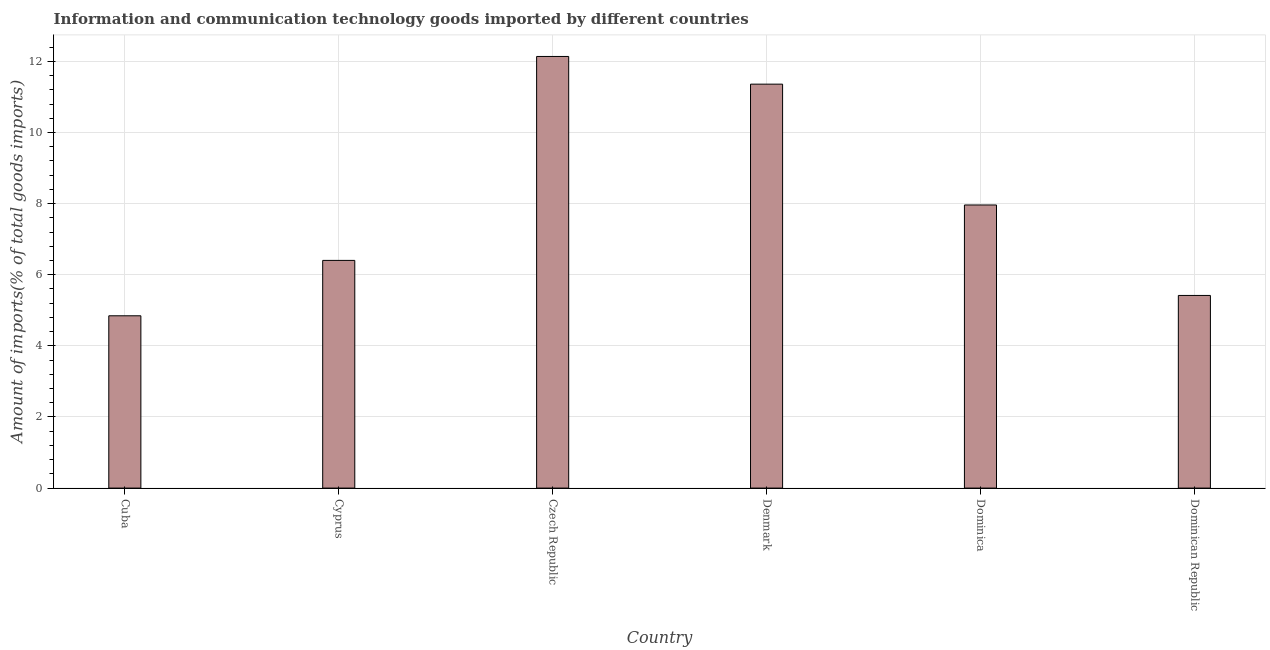Does the graph contain any zero values?
Make the answer very short. No. What is the title of the graph?
Give a very brief answer. Information and communication technology goods imported by different countries. What is the label or title of the X-axis?
Offer a very short reply. Country. What is the label or title of the Y-axis?
Give a very brief answer. Amount of imports(% of total goods imports). What is the amount of ict goods imports in Denmark?
Your answer should be compact. 11.36. Across all countries, what is the maximum amount of ict goods imports?
Your answer should be compact. 12.14. Across all countries, what is the minimum amount of ict goods imports?
Offer a very short reply. 4.85. In which country was the amount of ict goods imports maximum?
Your response must be concise. Czech Republic. In which country was the amount of ict goods imports minimum?
Your answer should be very brief. Cuba. What is the sum of the amount of ict goods imports?
Make the answer very short. 48.12. What is the difference between the amount of ict goods imports in Cuba and Dominican Republic?
Give a very brief answer. -0.57. What is the average amount of ict goods imports per country?
Offer a terse response. 8.02. What is the median amount of ict goods imports?
Keep it short and to the point. 7.18. In how many countries, is the amount of ict goods imports greater than 4.4 %?
Offer a very short reply. 6. What is the ratio of the amount of ict goods imports in Czech Republic to that in Denmark?
Ensure brevity in your answer.  1.07. Is the amount of ict goods imports in Cuba less than that in Czech Republic?
Your answer should be compact. Yes. What is the difference between the highest and the second highest amount of ict goods imports?
Offer a terse response. 0.78. Is the sum of the amount of ict goods imports in Cuba and Dominica greater than the maximum amount of ict goods imports across all countries?
Give a very brief answer. Yes. What is the difference between the highest and the lowest amount of ict goods imports?
Provide a succinct answer. 7.29. In how many countries, is the amount of ict goods imports greater than the average amount of ict goods imports taken over all countries?
Offer a terse response. 2. How many bars are there?
Offer a terse response. 6. Are all the bars in the graph horizontal?
Your answer should be compact. No. How many countries are there in the graph?
Give a very brief answer. 6. What is the difference between two consecutive major ticks on the Y-axis?
Give a very brief answer. 2. What is the Amount of imports(% of total goods imports) in Cuba?
Make the answer very short. 4.85. What is the Amount of imports(% of total goods imports) in Cyprus?
Give a very brief answer. 6.4. What is the Amount of imports(% of total goods imports) of Czech Republic?
Your response must be concise. 12.14. What is the Amount of imports(% of total goods imports) of Denmark?
Give a very brief answer. 11.36. What is the Amount of imports(% of total goods imports) of Dominica?
Make the answer very short. 7.96. What is the Amount of imports(% of total goods imports) in Dominican Republic?
Give a very brief answer. 5.42. What is the difference between the Amount of imports(% of total goods imports) in Cuba and Cyprus?
Offer a terse response. -1.56. What is the difference between the Amount of imports(% of total goods imports) in Cuba and Czech Republic?
Ensure brevity in your answer.  -7.29. What is the difference between the Amount of imports(% of total goods imports) in Cuba and Denmark?
Keep it short and to the point. -6.51. What is the difference between the Amount of imports(% of total goods imports) in Cuba and Dominica?
Make the answer very short. -3.12. What is the difference between the Amount of imports(% of total goods imports) in Cuba and Dominican Republic?
Offer a terse response. -0.57. What is the difference between the Amount of imports(% of total goods imports) in Cyprus and Czech Republic?
Make the answer very short. -5.73. What is the difference between the Amount of imports(% of total goods imports) in Cyprus and Denmark?
Your answer should be compact. -4.96. What is the difference between the Amount of imports(% of total goods imports) in Cyprus and Dominica?
Offer a terse response. -1.56. What is the difference between the Amount of imports(% of total goods imports) in Cyprus and Dominican Republic?
Provide a short and direct response. 0.99. What is the difference between the Amount of imports(% of total goods imports) in Czech Republic and Denmark?
Offer a terse response. 0.78. What is the difference between the Amount of imports(% of total goods imports) in Czech Republic and Dominica?
Your response must be concise. 4.18. What is the difference between the Amount of imports(% of total goods imports) in Czech Republic and Dominican Republic?
Ensure brevity in your answer.  6.72. What is the difference between the Amount of imports(% of total goods imports) in Denmark and Dominica?
Keep it short and to the point. 3.4. What is the difference between the Amount of imports(% of total goods imports) in Denmark and Dominican Republic?
Your response must be concise. 5.94. What is the difference between the Amount of imports(% of total goods imports) in Dominica and Dominican Republic?
Ensure brevity in your answer.  2.54. What is the ratio of the Amount of imports(% of total goods imports) in Cuba to that in Cyprus?
Give a very brief answer. 0.76. What is the ratio of the Amount of imports(% of total goods imports) in Cuba to that in Czech Republic?
Your answer should be compact. 0.4. What is the ratio of the Amount of imports(% of total goods imports) in Cuba to that in Denmark?
Make the answer very short. 0.43. What is the ratio of the Amount of imports(% of total goods imports) in Cuba to that in Dominica?
Keep it short and to the point. 0.61. What is the ratio of the Amount of imports(% of total goods imports) in Cuba to that in Dominican Republic?
Your response must be concise. 0.89. What is the ratio of the Amount of imports(% of total goods imports) in Cyprus to that in Czech Republic?
Ensure brevity in your answer.  0.53. What is the ratio of the Amount of imports(% of total goods imports) in Cyprus to that in Denmark?
Provide a succinct answer. 0.56. What is the ratio of the Amount of imports(% of total goods imports) in Cyprus to that in Dominica?
Provide a succinct answer. 0.8. What is the ratio of the Amount of imports(% of total goods imports) in Cyprus to that in Dominican Republic?
Make the answer very short. 1.18. What is the ratio of the Amount of imports(% of total goods imports) in Czech Republic to that in Denmark?
Provide a short and direct response. 1.07. What is the ratio of the Amount of imports(% of total goods imports) in Czech Republic to that in Dominica?
Keep it short and to the point. 1.52. What is the ratio of the Amount of imports(% of total goods imports) in Czech Republic to that in Dominican Republic?
Offer a very short reply. 2.24. What is the ratio of the Amount of imports(% of total goods imports) in Denmark to that in Dominica?
Provide a short and direct response. 1.43. What is the ratio of the Amount of imports(% of total goods imports) in Denmark to that in Dominican Republic?
Give a very brief answer. 2.1. What is the ratio of the Amount of imports(% of total goods imports) in Dominica to that in Dominican Republic?
Give a very brief answer. 1.47. 